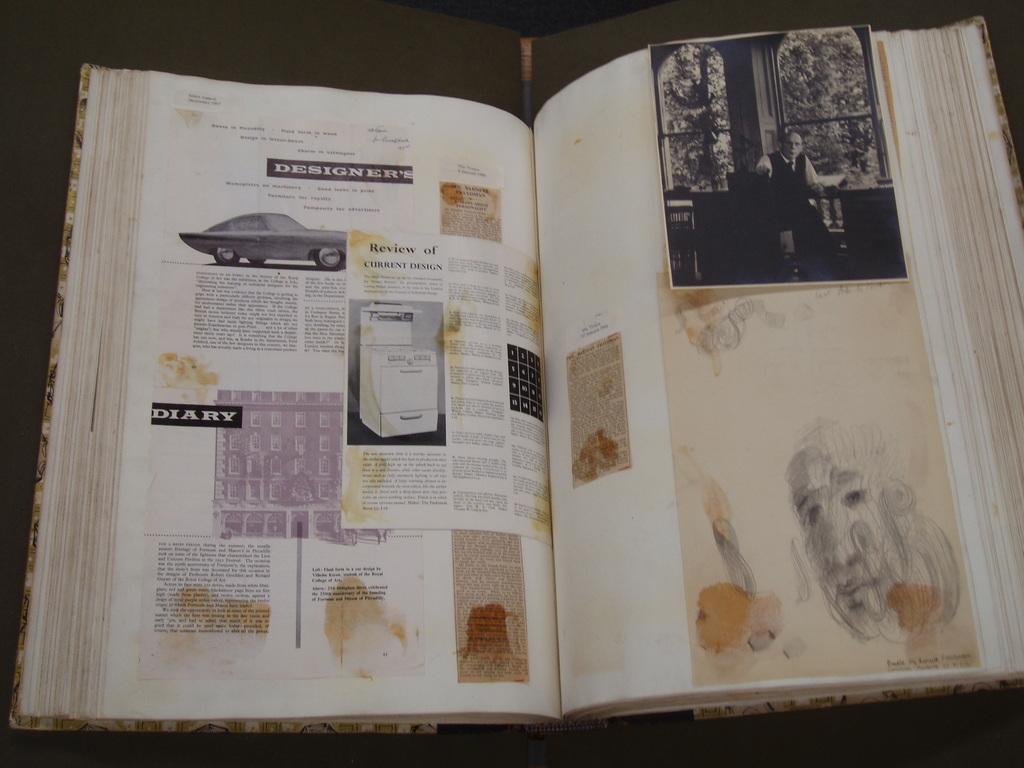What is the book about?
Your answer should be very brief. Designers. 